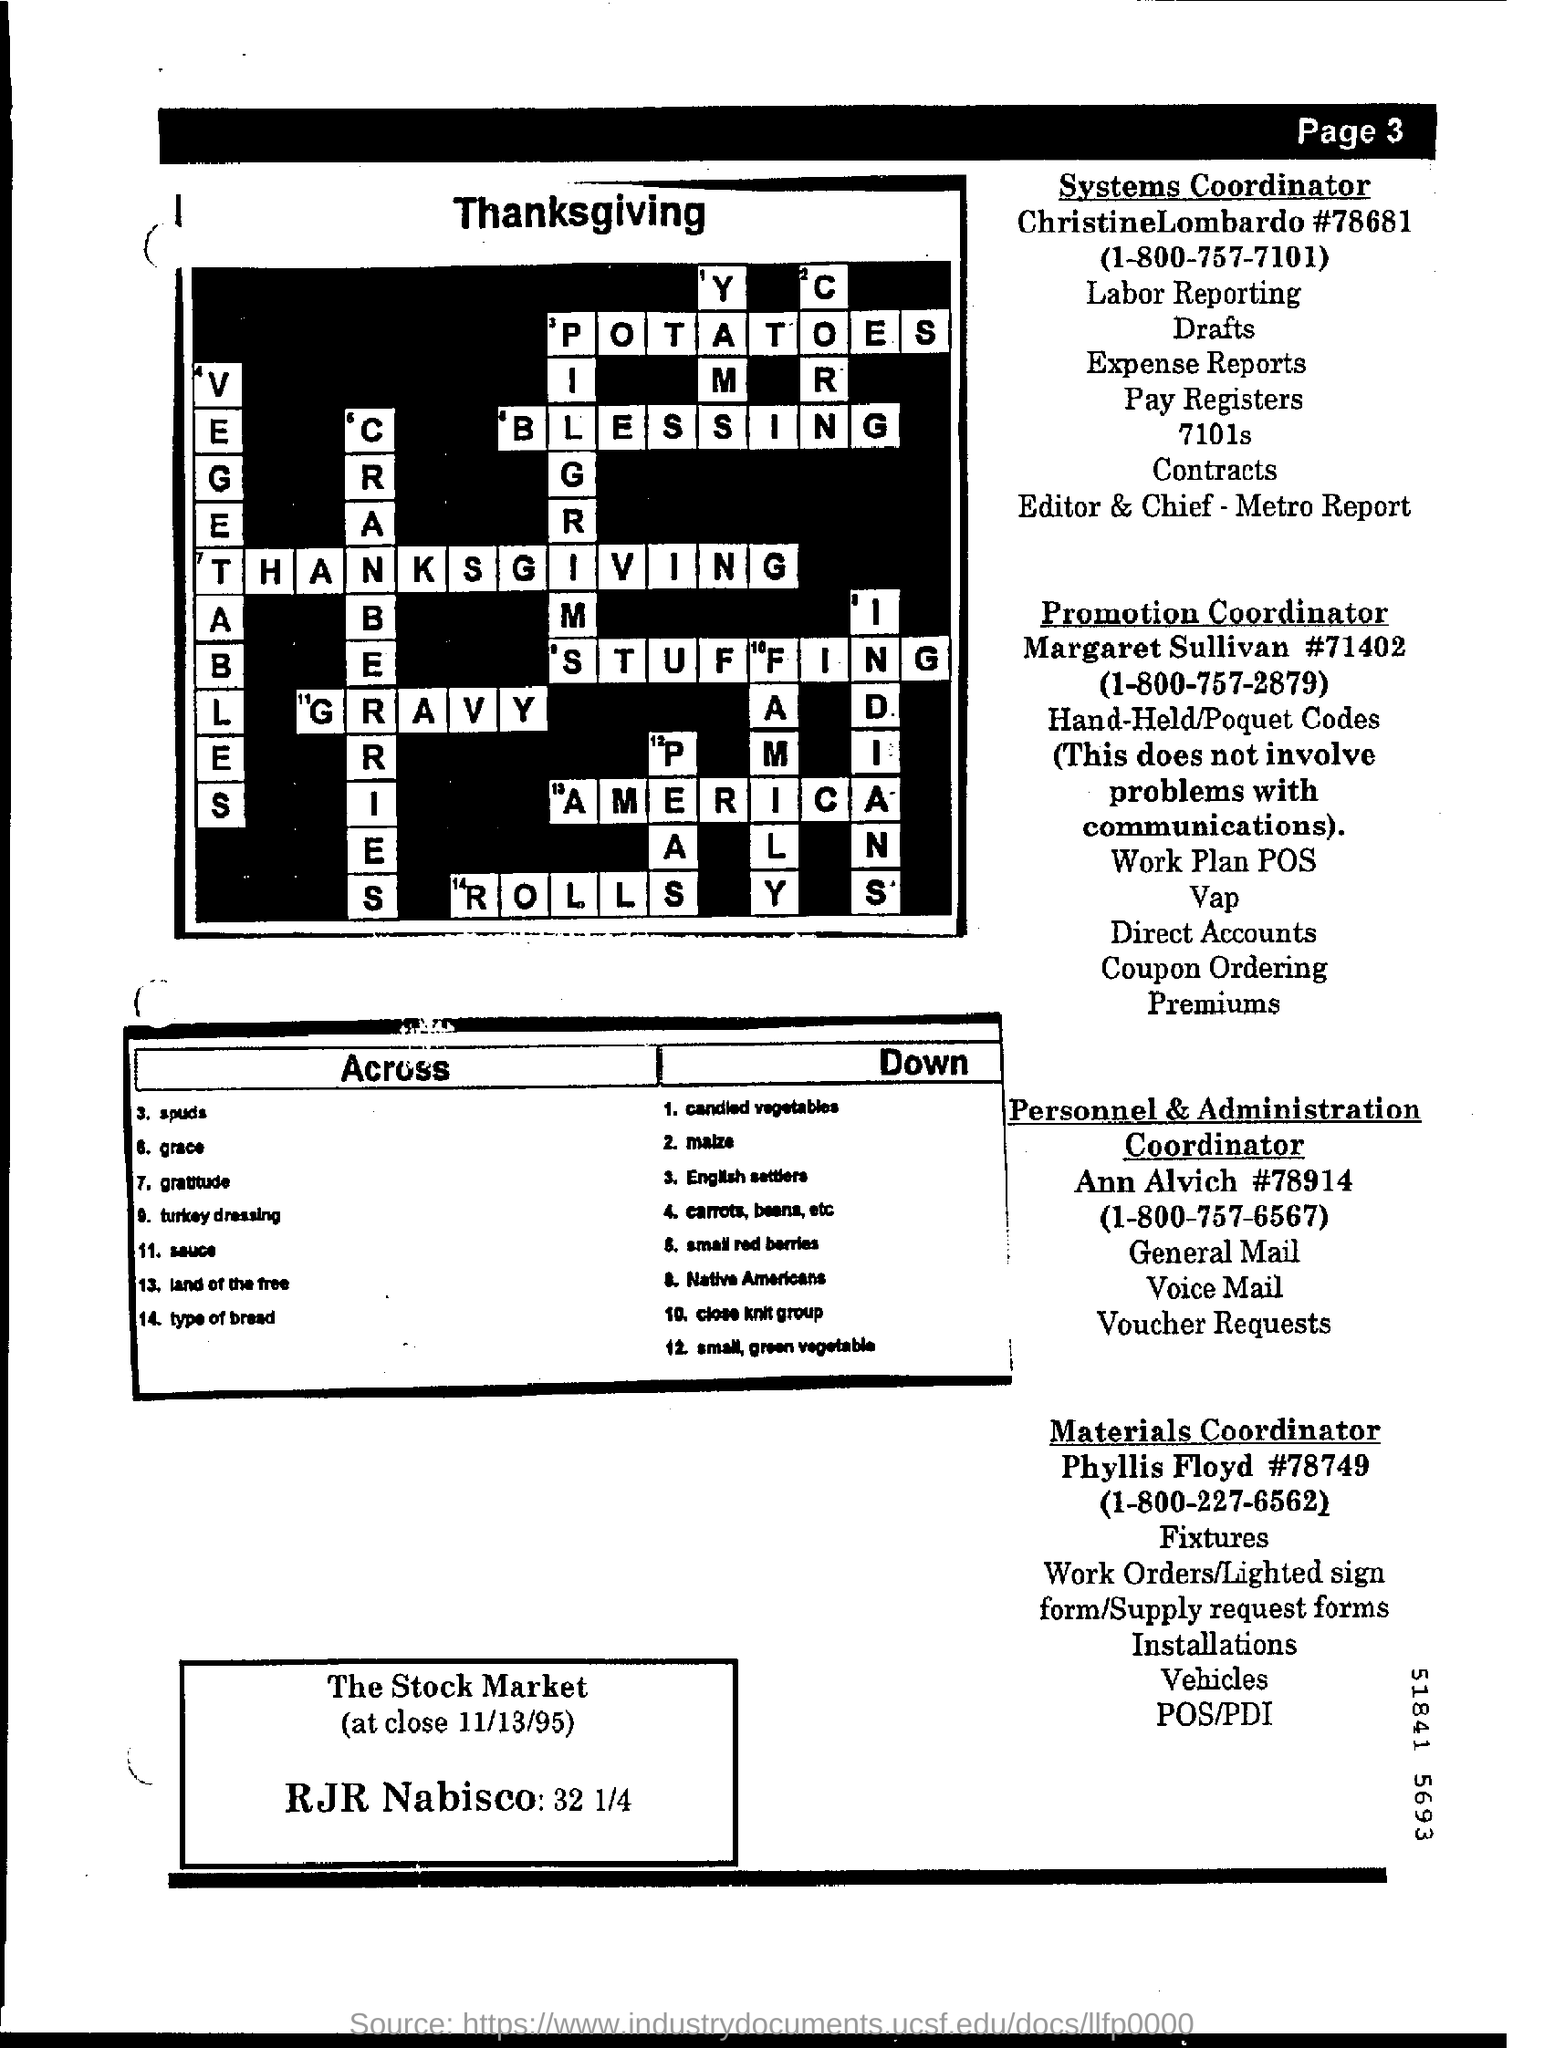Who is the Systems Coordinator?
Ensure brevity in your answer.  ChristineLombardo. Who is the Promotion Coordinator?
Your answer should be very brief. Margaret Sullivan. 